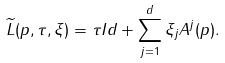Convert formula to latex. <formula><loc_0><loc_0><loc_500><loc_500>\widetilde { L } ( p , \tau , \xi ) = \tau I d + \sum _ { j = 1 } ^ { d } \xi _ { j } A ^ { j } ( p ) . \\</formula> 